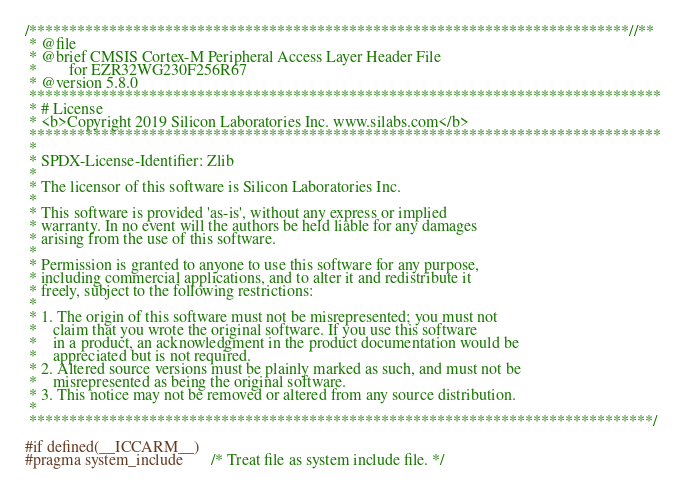Convert code to text. <code><loc_0><loc_0><loc_500><loc_500><_C_>/***************************************************************************//**
 * @file
 * @brief CMSIS Cortex-M Peripheral Access Layer Header File
 *        for EZR32WG230F256R67
 * @version 5.8.0
 *******************************************************************************
 * # License
 * <b>Copyright 2019 Silicon Laboratories Inc. www.silabs.com</b>
 *******************************************************************************
 *
 * SPDX-License-Identifier: Zlib
 *
 * The licensor of this software is Silicon Laboratories Inc.
 *
 * This software is provided 'as-is', without any express or implied
 * warranty. In no event will the authors be held liable for any damages
 * arising from the use of this software.
 *
 * Permission is granted to anyone to use this software for any purpose,
 * including commercial applications, and to alter it and redistribute it
 * freely, subject to the following restrictions:
 *
 * 1. The origin of this software must not be misrepresented; you must not
 *    claim that you wrote the original software. If you use this software
 *    in a product, an acknowledgment in the product documentation would be
 *    appreciated but is not required.
 * 2. Altered source versions must be plainly marked as such, and must not be
 *    misrepresented as being the original software.
 * 3. This notice may not be removed or altered from any source distribution.
 *
 ******************************************************************************/

#if defined(__ICCARM__)
#pragma system_include       /* Treat file as system include file. */</code> 